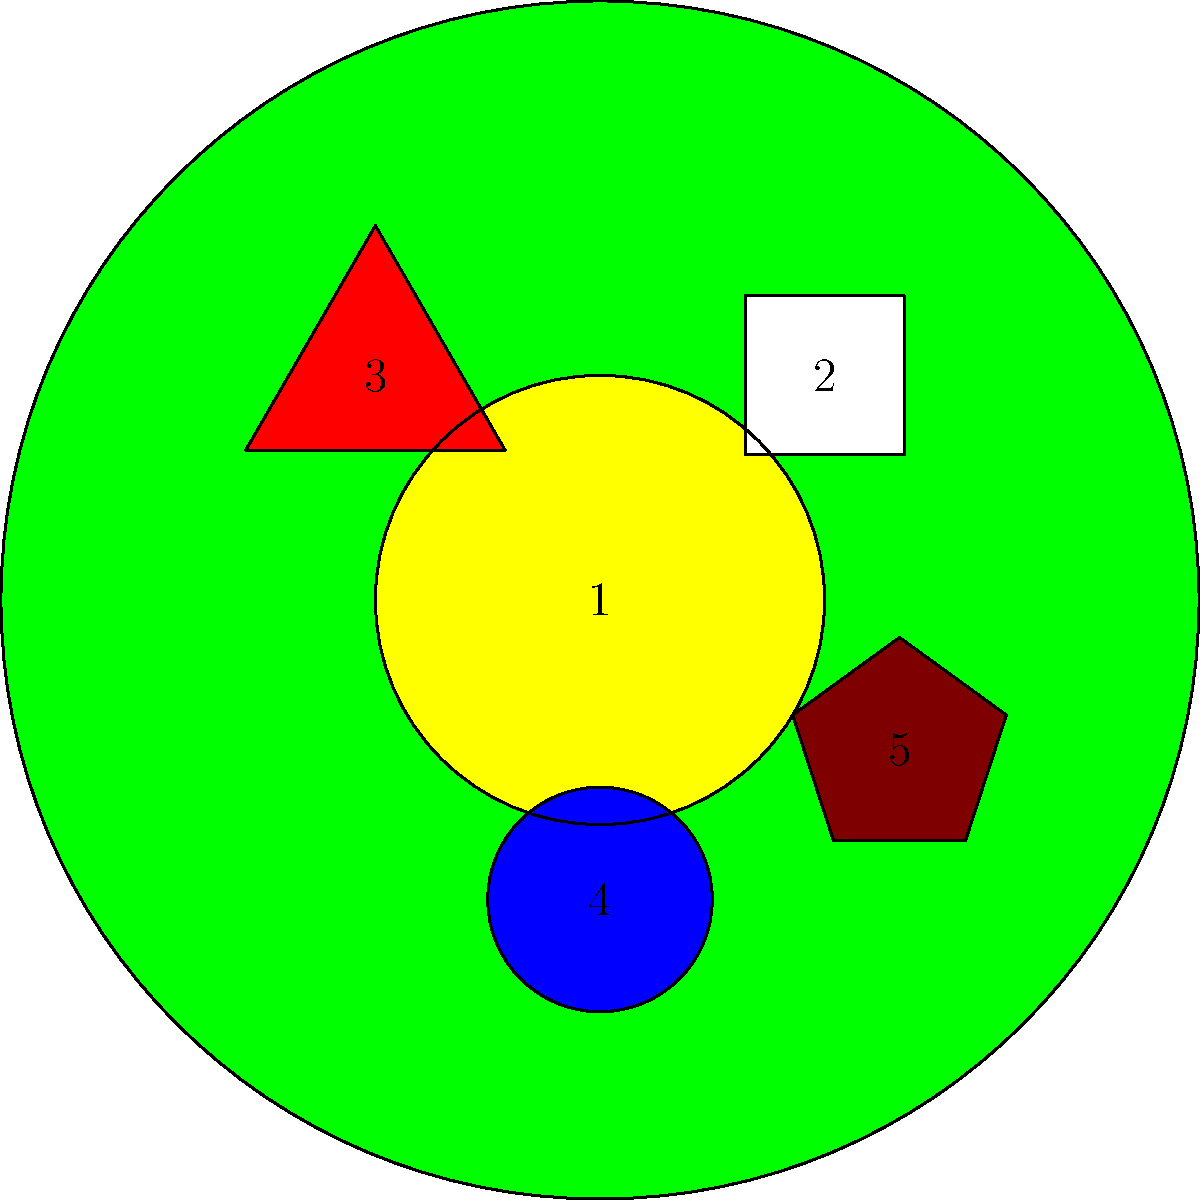In the collage above, which numbered shape represents the iconic Christ the Redeemer statue, a symbol closely associated with Brazilian culture and tourism? To identify the symbol representing Christ the Redeemer, let's analyze each shape:

1. The large green circle represents the Brazilian flag's main color.
2. The white square represents Christ the Redeemer statue.
3. The red triangle likely symbolizes the colorful Carnival celebrations.
4. The blue circle could represent soccer, a popular sport in Brazil.
5. The brown pentagon might represent coffee beans, as Brazil is a major coffee producer.

Christ the Redeemer is typically depicted with outstretched arms, which can be simplified to a cross-like or square shape. In this collage, the white square (number 2) best represents this iconic statue.

The statue's location at the top of the image also aligns with its actual location atop Corcovado Mountain in Rio de Janeiro, overlooking the city.
Answer: 2 